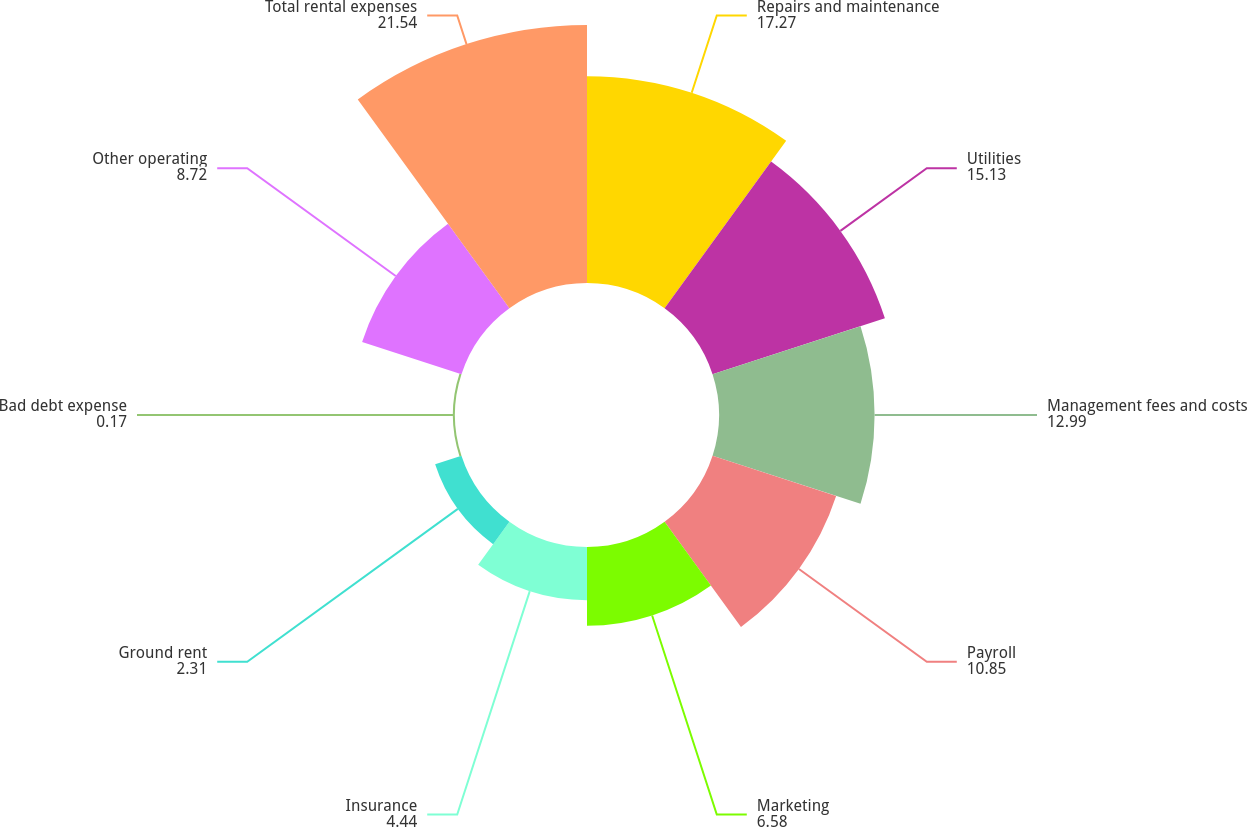<chart> <loc_0><loc_0><loc_500><loc_500><pie_chart><fcel>Repairs and maintenance<fcel>Utilities<fcel>Management fees and costs<fcel>Payroll<fcel>Marketing<fcel>Insurance<fcel>Ground rent<fcel>Bad debt expense<fcel>Other operating<fcel>Total rental expenses<nl><fcel>17.27%<fcel>15.13%<fcel>12.99%<fcel>10.85%<fcel>6.58%<fcel>4.44%<fcel>2.31%<fcel>0.17%<fcel>8.72%<fcel>21.54%<nl></chart> 